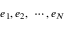<formula> <loc_0><loc_0><loc_500><loc_500>e _ { 1 } , e _ { 2 } , \cdots , e _ { N }</formula> 